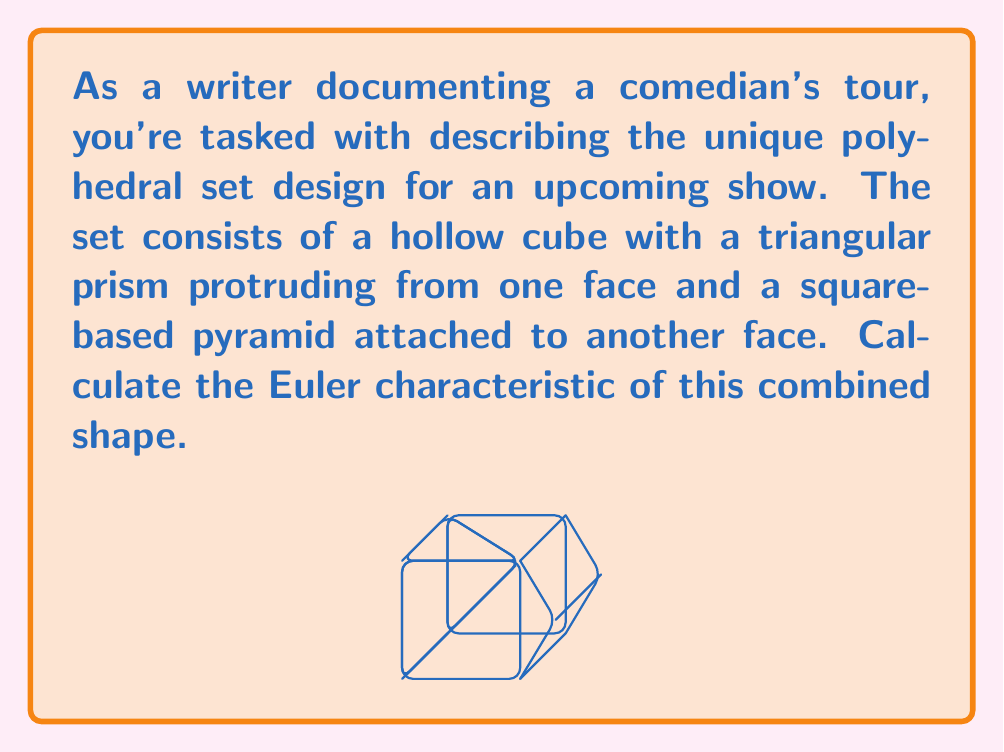Teach me how to tackle this problem. To calculate the Euler characteristic ($\chi$) of this combined shape, we need to count the number of vertices (V), edges (E), and faces (F), and then apply the formula:

$$\chi = V - E + F$$

Let's break it down step by step:

1) Cube:
   - 8 vertices
   - 12 edges
   - 6 faces

2) Triangular prism:
   - Adds 1 new vertex
   - Adds 3 new edges
   - Adds 3 new faces

3) Square-based pyramid:
   - Adds 1 new vertex
   - Adds 4 new edges
   - Adds 4 new faces

Now, let's combine these:

Vertices (V): 8 + 1 + 1 = 10
Edges (E): 12 + 3 + 4 = 19
Faces (F): 6 + 3 + 4 = 13

Applying the Euler characteristic formula:

$$\chi = V - E + F = 10 - 19 + 13 = 4$$

This result is consistent with the Euler characteristic of a solid polyhedron, which is always 2. Our shape is essentially a sphere (Euler characteristic 2) with two additional holes (each reducing the Euler characteristic by 1), resulting in a final Euler characteristic of 4.
Answer: $\chi = 4$ 